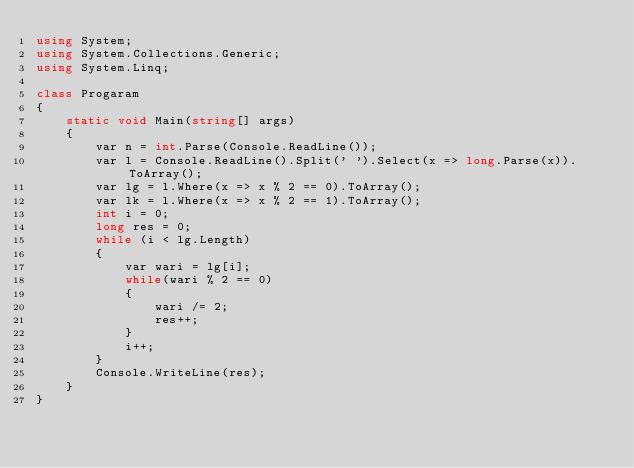<code> <loc_0><loc_0><loc_500><loc_500><_C#_>using System;
using System.Collections.Generic;
using System.Linq;

class Progaram
{
    static void Main(string[] args)
    {
        var n = int.Parse(Console.ReadLine());
        var l = Console.ReadLine().Split(' ').Select(x => long.Parse(x)).ToArray();
        var lg = l.Where(x => x % 2 == 0).ToArray();
        var lk = l.Where(x => x % 2 == 1).ToArray();
        int i = 0;
        long res = 0;
        while (i < lg.Length)
        {
            var wari = lg[i];
            while(wari % 2 == 0)
            {
                wari /= 2;
                res++;
            }
            i++;
        }
        Console.WriteLine(res);
    }
}
</code> 